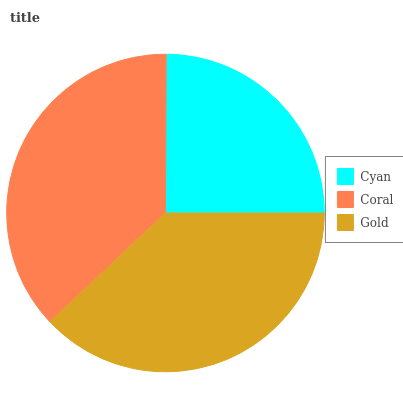Is Cyan the minimum?
Answer yes or no. Yes. Is Gold the maximum?
Answer yes or no. Yes. Is Coral the minimum?
Answer yes or no. No. Is Coral the maximum?
Answer yes or no. No. Is Coral greater than Cyan?
Answer yes or no. Yes. Is Cyan less than Coral?
Answer yes or no. Yes. Is Cyan greater than Coral?
Answer yes or no. No. Is Coral less than Cyan?
Answer yes or no. No. Is Coral the high median?
Answer yes or no. Yes. Is Coral the low median?
Answer yes or no. Yes. Is Gold the high median?
Answer yes or no. No. Is Cyan the low median?
Answer yes or no. No. 